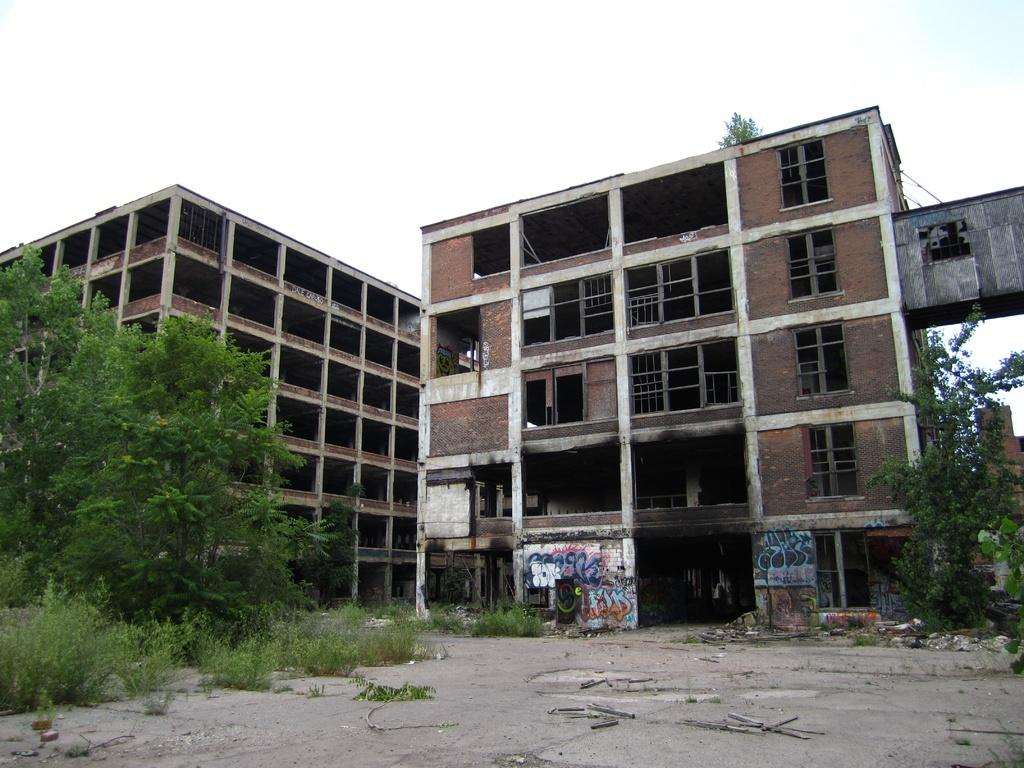What is happening in the image? There are buildings under construction in the image. What type of vegetation can be seen in the image? There are trees, plants, and shrubs in the image. What can be seen on the ground in the image? The ground is visible in the image. What is visible in the background of the image? The sky is visible in the image. How many books can be seen on the car in the image? There is no car or books present in the image. 